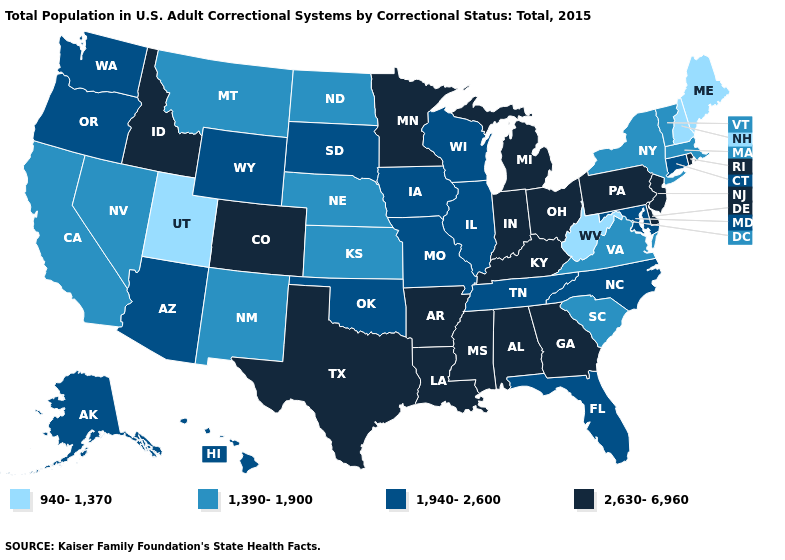Does Iowa have the lowest value in the USA?
Quick response, please. No. Does Hawaii have the highest value in the USA?
Be succinct. No. Does New Jersey have the highest value in the USA?
Be succinct. Yes. What is the value of Florida?
Quick response, please. 1,940-2,600. Among the states that border Colorado , does New Mexico have the lowest value?
Short answer required. No. Which states hav the highest value in the West?
Be succinct. Colorado, Idaho. What is the value of Massachusetts?
Short answer required. 1,390-1,900. What is the value of Ohio?
Answer briefly. 2,630-6,960. Does Alabama have the highest value in the USA?
Write a very short answer. Yes. Among the states that border Texas , which have the lowest value?
Keep it brief. New Mexico. Does the first symbol in the legend represent the smallest category?
Answer briefly. Yes. Which states have the lowest value in the USA?
Quick response, please. Maine, New Hampshire, Utah, West Virginia. Name the states that have a value in the range 2,630-6,960?
Write a very short answer. Alabama, Arkansas, Colorado, Delaware, Georgia, Idaho, Indiana, Kentucky, Louisiana, Michigan, Minnesota, Mississippi, New Jersey, Ohio, Pennsylvania, Rhode Island, Texas. What is the lowest value in the USA?
Write a very short answer. 940-1,370. What is the value of Illinois?
Short answer required. 1,940-2,600. 